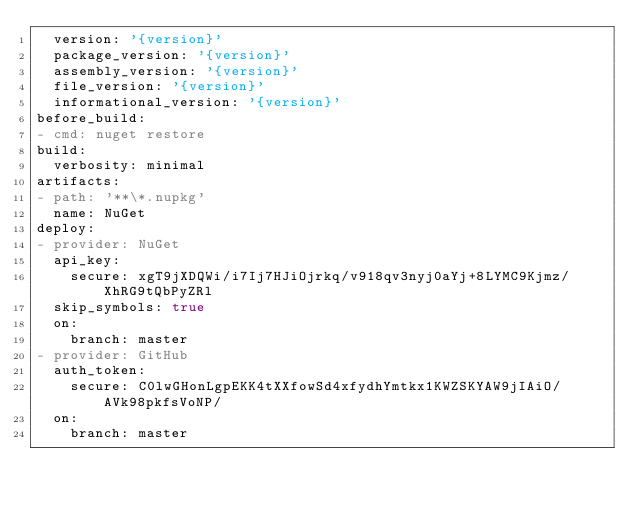<code> <loc_0><loc_0><loc_500><loc_500><_YAML_>  version: '{version}'
  package_version: '{version}'
  assembly_version: '{version}'
  file_version: '{version}'
  informational_version: '{version}'
before_build:
- cmd: nuget restore
build:
  verbosity: minimal
artifacts:
- path: '**\*.nupkg'
  name: NuGet
deploy:
- provider: NuGet
  api_key:
    secure: xgT9jXDQWi/i7Ij7HJiOjrkq/v918qv3nyj0aYj+8LYMC9Kjmz/XhRG9tQbPyZRl
  skip_symbols: true
  on:
    branch: master
- provider: GitHub
  auth_token:
    secure: C0lwGHonLgpEKK4tXXfowSd4xfydhYmtkx1KWZSKYAW9jIAiO/AVk98pkfsVoNP/
  on:
    branch: master</code> 